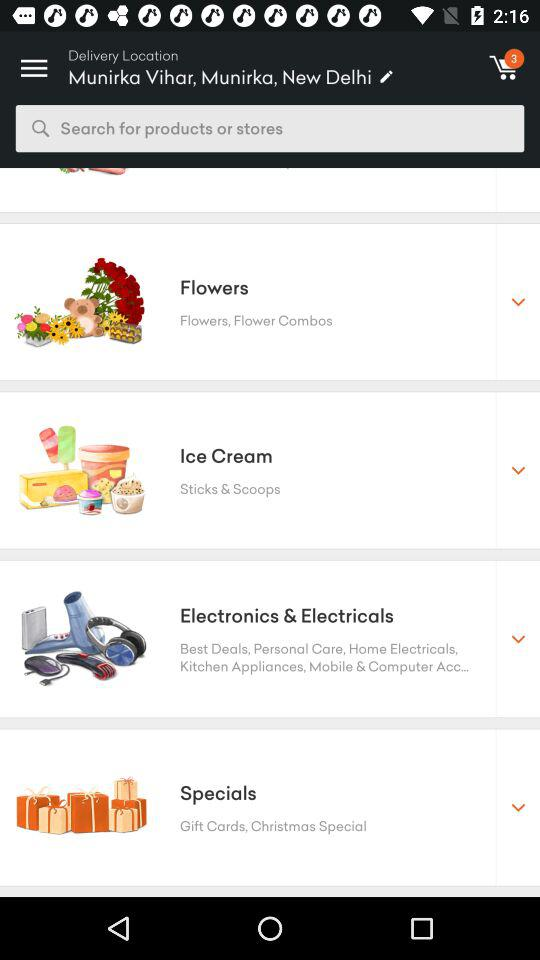How many items are added to the cart? There are 3 items added to the cart. 